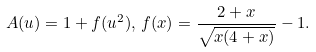<formula> <loc_0><loc_0><loc_500><loc_500>A ( u ) = 1 + f ( u ^ { 2 } ) , \, f ( x ) = \frac { 2 + x } { \sqrt { x ( 4 + x ) } } - 1 .</formula> 